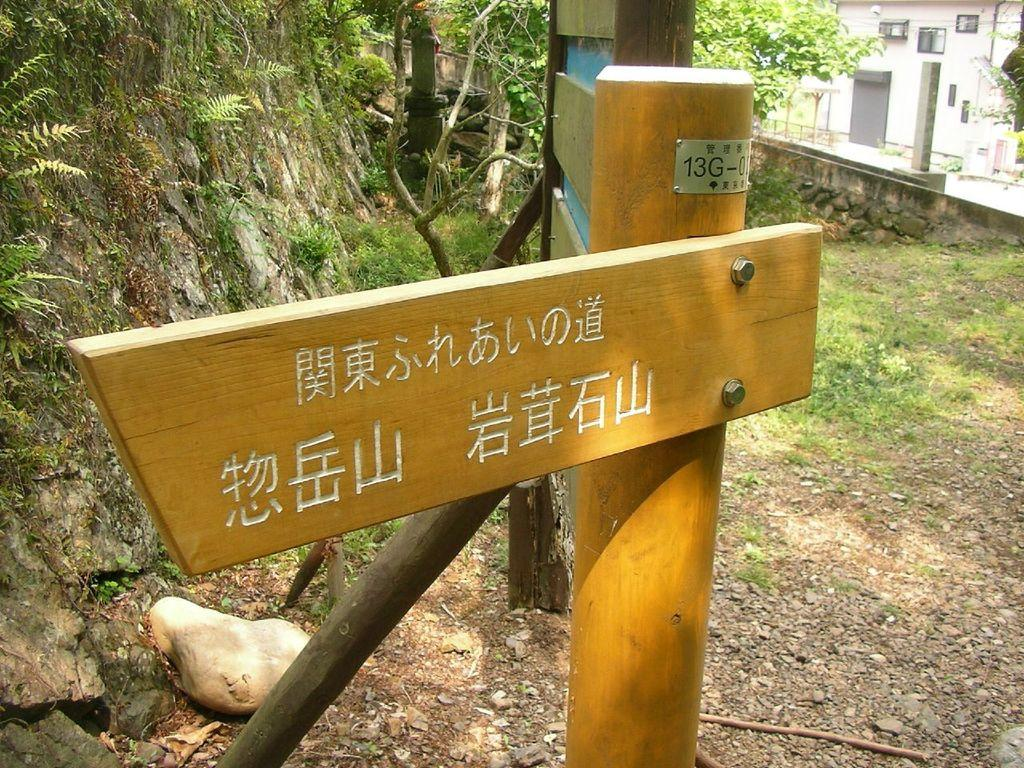What is the main object on the pole in the image? There is a wooden board on a pole in the image. What can be seen on the rock in the image? The rock in the image is covered with plants. What type of structures can be seen in the image? There are buildings visible in the image. How many fish can be seen swimming around the wooden board in the image? There are no fish present in the image; it features a wooden board on a pole and a rock covered with plants. 